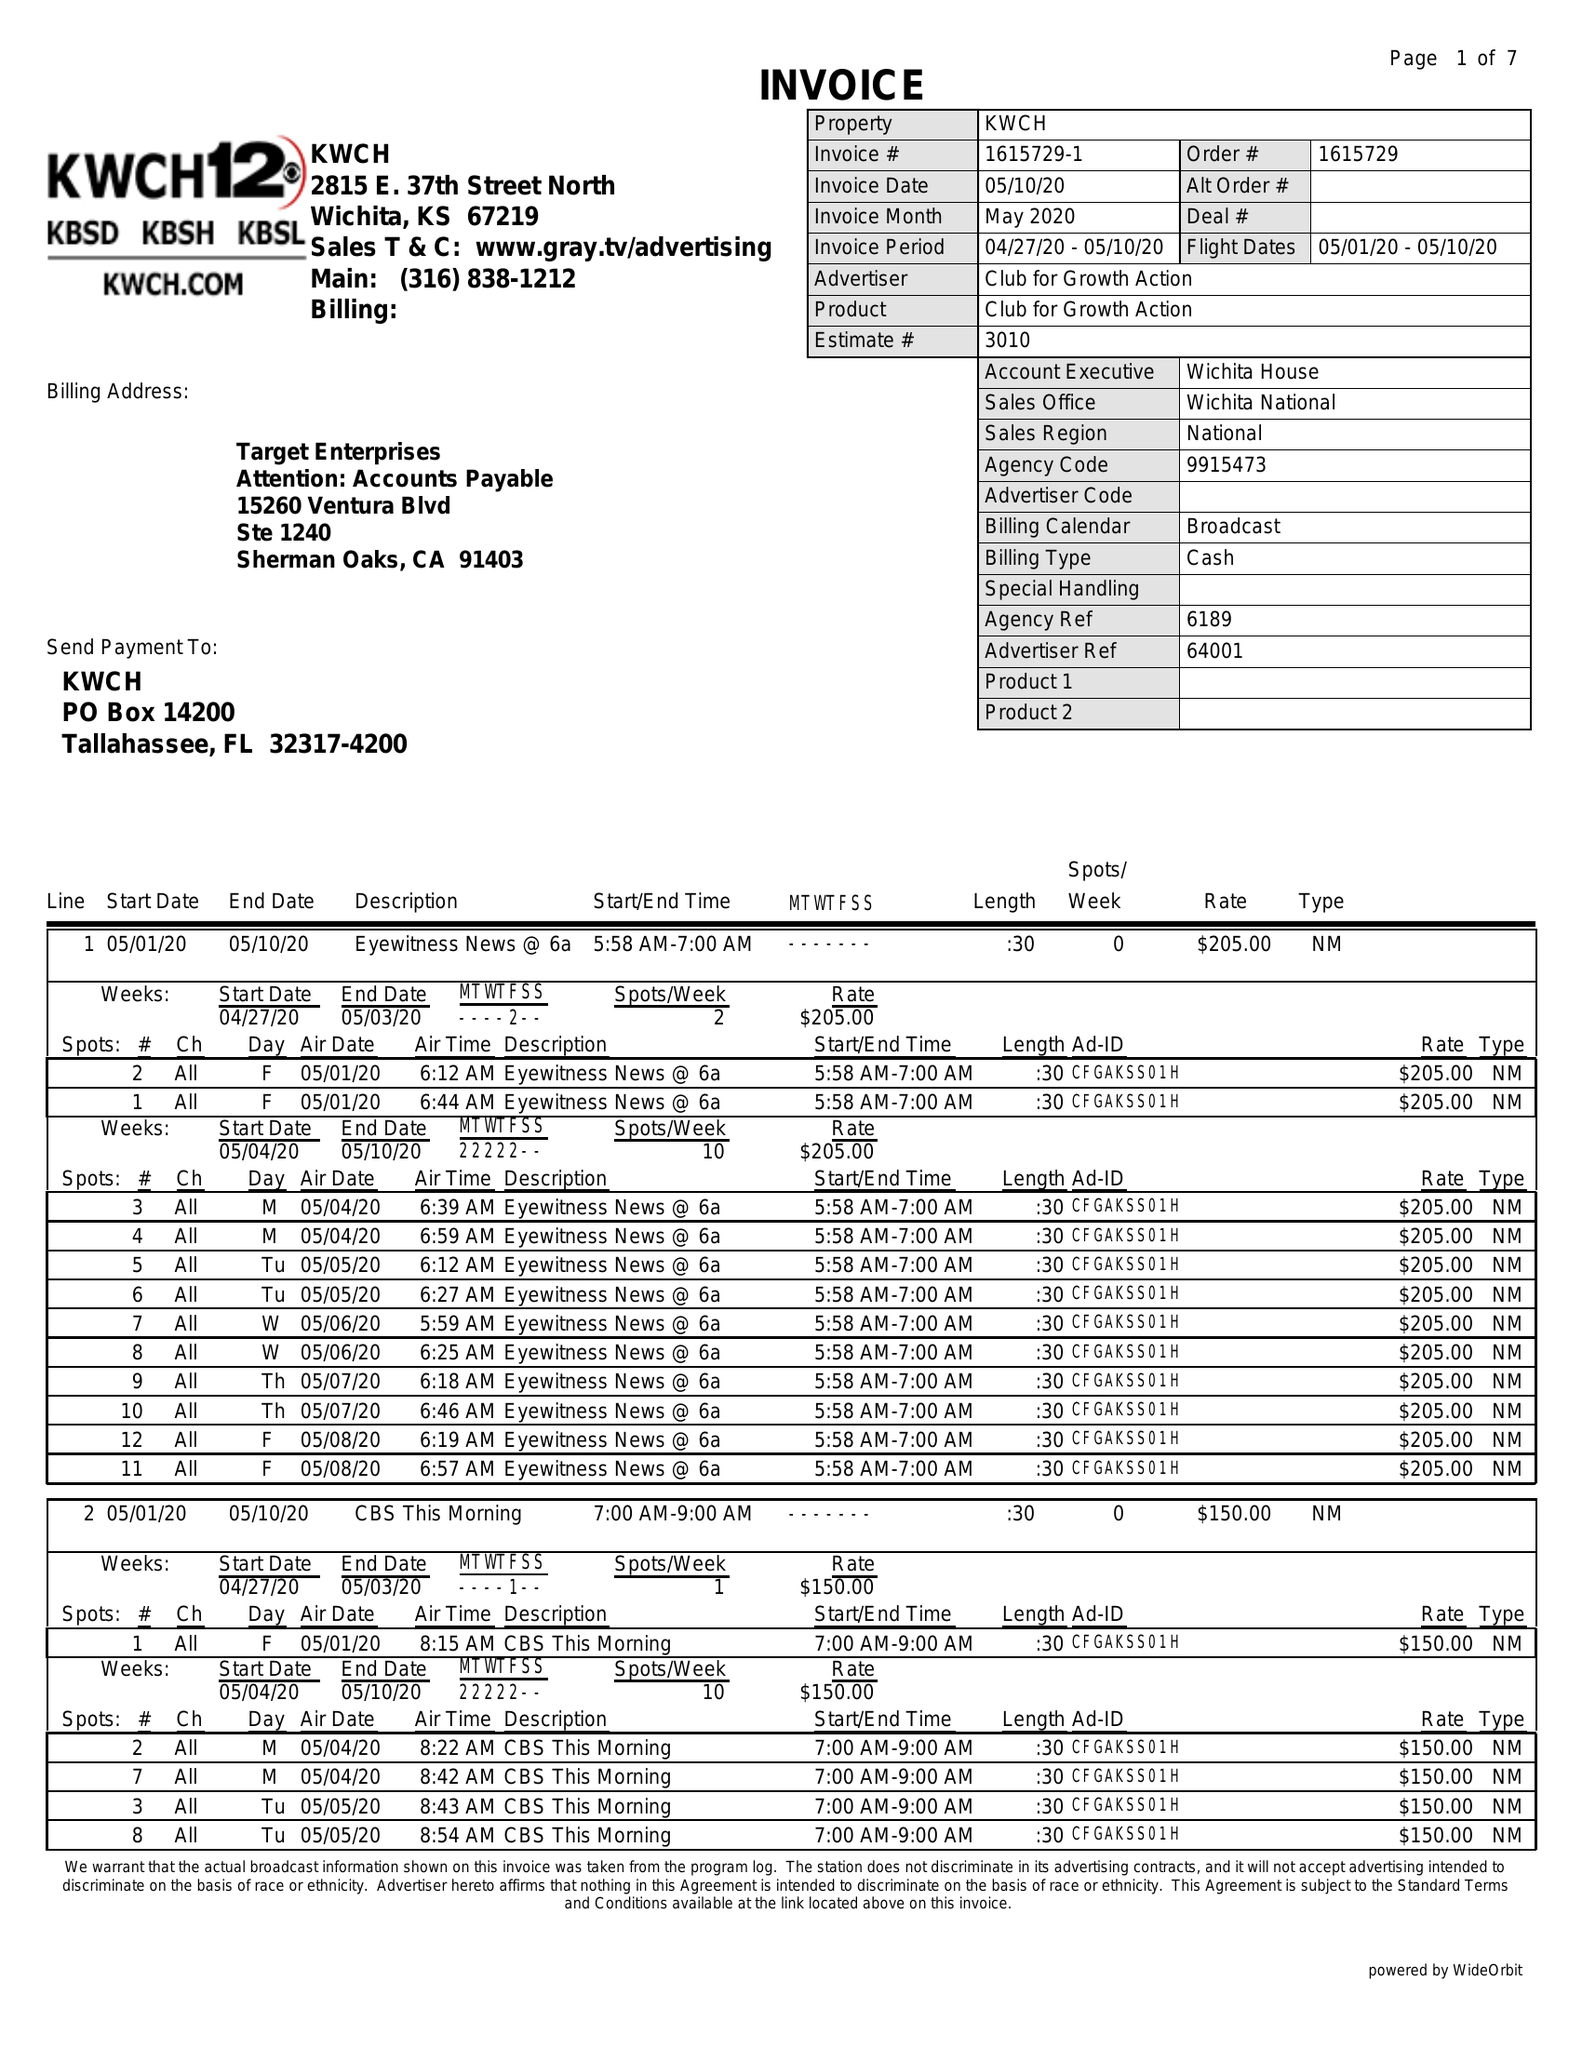What is the value for the gross_amount?
Answer the question using a single word or phrase. 25152.00 